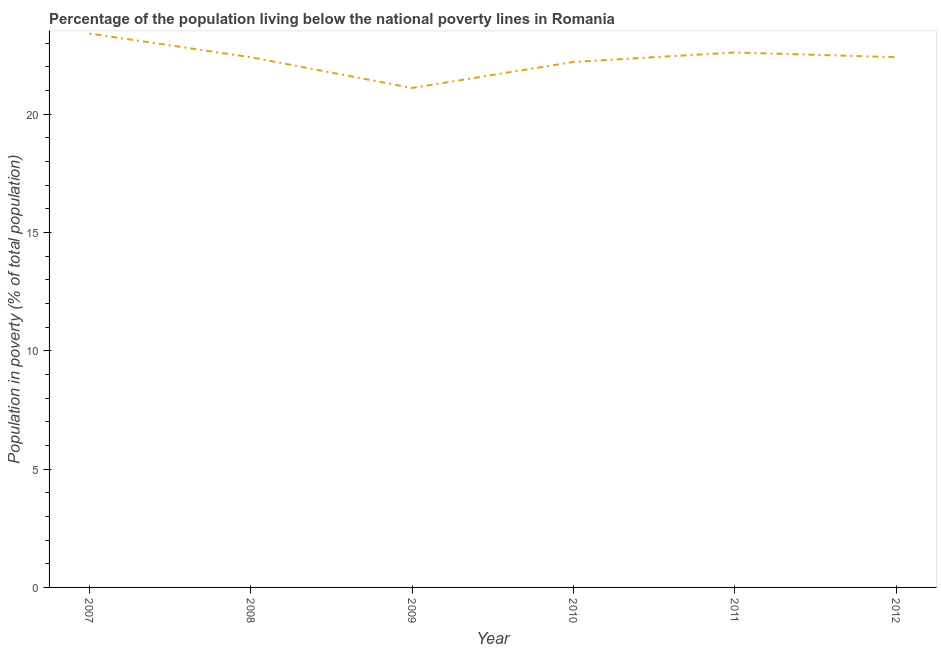What is the percentage of population living below poverty line in 2010?
Make the answer very short. 22.2. Across all years, what is the maximum percentage of population living below poverty line?
Your response must be concise. 23.4. Across all years, what is the minimum percentage of population living below poverty line?
Offer a terse response. 21.1. In which year was the percentage of population living below poverty line minimum?
Your answer should be compact. 2009. What is the sum of the percentage of population living below poverty line?
Your response must be concise. 134.1. What is the difference between the percentage of population living below poverty line in 2007 and 2010?
Offer a very short reply. 1.2. What is the average percentage of population living below poverty line per year?
Provide a succinct answer. 22.35. What is the median percentage of population living below poverty line?
Keep it short and to the point. 22.4. In how many years, is the percentage of population living below poverty line greater than 8 %?
Provide a short and direct response. 6. Do a majority of the years between 2009 and 2012 (inclusive) have percentage of population living below poverty line greater than 2 %?
Provide a succinct answer. Yes. What is the ratio of the percentage of population living below poverty line in 2009 to that in 2012?
Ensure brevity in your answer.  0.94. Is the difference between the percentage of population living below poverty line in 2007 and 2010 greater than the difference between any two years?
Your response must be concise. No. What is the difference between the highest and the second highest percentage of population living below poverty line?
Keep it short and to the point. 0.8. What is the difference between the highest and the lowest percentage of population living below poverty line?
Offer a very short reply. 2.3. How many lines are there?
Offer a terse response. 1. How many years are there in the graph?
Your answer should be compact. 6. What is the difference between two consecutive major ticks on the Y-axis?
Make the answer very short. 5. Does the graph contain any zero values?
Provide a short and direct response. No. What is the title of the graph?
Keep it short and to the point. Percentage of the population living below the national poverty lines in Romania. What is the label or title of the Y-axis?
Provide a succinct answer. Population in poverty (% of total population). What is the Population in poverty (% of total population) of 2007?
Offer a very short reply. 23.4. What is the Population in poverty (% of total population) of 2008?
Make the answer very short. 22.4. What is the Population in poverty (% of total population) of 2009?
Offer a very short reply. 21.1. What is the Population in poverty (% of total population) of 2010?
Give a very brief answer. 22.2. What is the Population in poverty (% of total population) of 2011?
Your response must be concise. 22.6. What is the Population in poverty (% of total population) in 2012?
Give a very brief answer. 22.4. What is the difference between the Population in poverty (% of total population) in 2007 and 2009?
Ensure brevity in your answer.  2.3. What is the difference between the Population in poverty (% of total population) in 2007 and 2010?
Your response must be concise. 1.2. What is the difference between the Population in poverty (% of total population) in 2007 and 2011?
Offer a terse response. 0.8. What is the difference between the Population in poverty (% of total population) in 2008 and 2010?
Ensure brevity in your answer.  0.2. What is the difference between the Population in poverty (% of total population) in 2009 and 2010?
Keep it short and to the point. -1.1. What is the difference between the Population in poverty (% of total population) in 2009 and 2011?
Ensure brevity in your answer.  -1.5. What is the difference between the Population in poverty (% of total population) in 2010 and 2012?
Your response must be concise. -0.2. What is the difference between the Population in poverty (% of total population) in 2011 and 2012?
Provide a succinct answer. 0.2. What is the ratio of the Population in poverty (% of total population) in 2007 to that in 2008?
Your answer should be very brief. 1.04. What is the ratio of the Population in poverty (% of total population) in 2007 to that in 2009?
Provide a succinct answer. 1.11. What is the ratio of the Population in poverty (% of total population) in 2007 to that in 2010?
Keep it short and to the point. 1.05. What is the ratio of the Population in poverty (% of total population) in 2007 to that in 2011?
Ensure brevity in your answer.  1.03. What is the ratio of the Population in poverty (% of total population) in 2007 to that in 2012?
Ensure brevity in your answer.  1.04. What is the ratio of the Population in poverty (% of total population) in 2008 to that in 2009?
Your answer should be very brief. 1.06. What is the ratio of the Population in poverty (% of total population) in 2008 to that in 2010?
Provide a succinct answer. 1.01. What is the ratio of the Population in poverty (% of total population) in 2009 to that in 2011?
Provide a succinct answer. 0.93. What is the ratio of the Population in poverty (% of total population) in 2009 to that in 2012?
Provide a succinct answer. 0.94. What is the ratio of the Population in poverty (% of total population) in 2010 to that in 2011?
Make the answer very short. 0.98. 